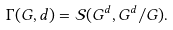Convert formula to latex. <formula><loc_0><loc_0><loc_500><loc_500>\Gamma ( G , d ) = \mathcal { S } ( G ^ { d } , G ^ { d } / G ) .</formula> 